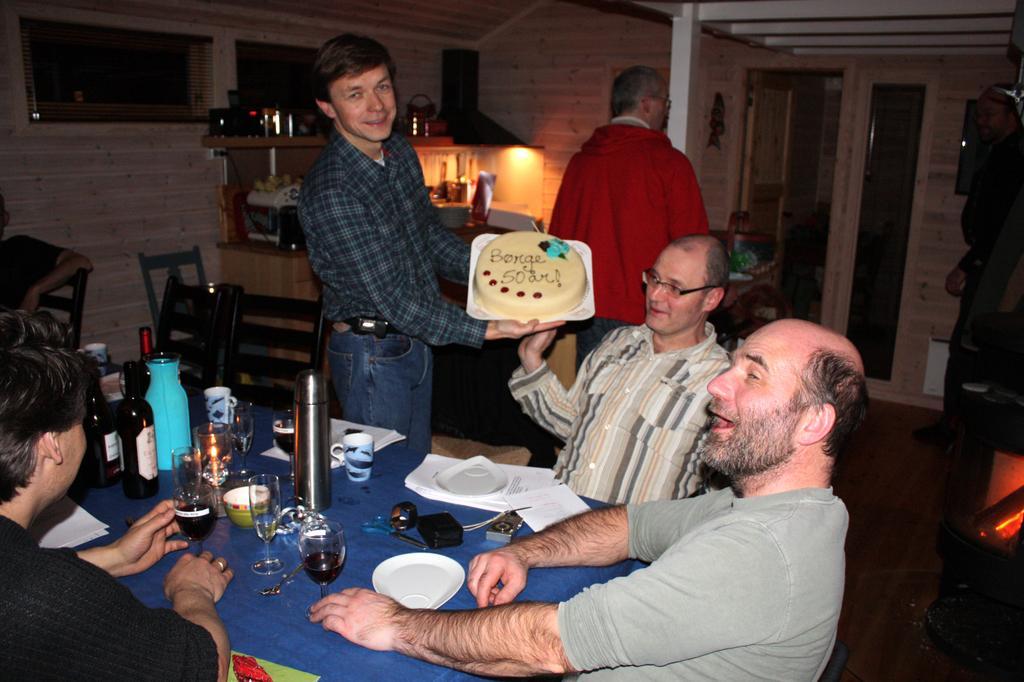Can you describe this image briefly? In this picture we can see a group of people where some are sitting on chairs and some are standing where a man is holding a cake with his hands and smiling and in front of them on table we can see bottles, glasses, cups, bowl, papers and in the background we can see some objects on a rack, windows. 